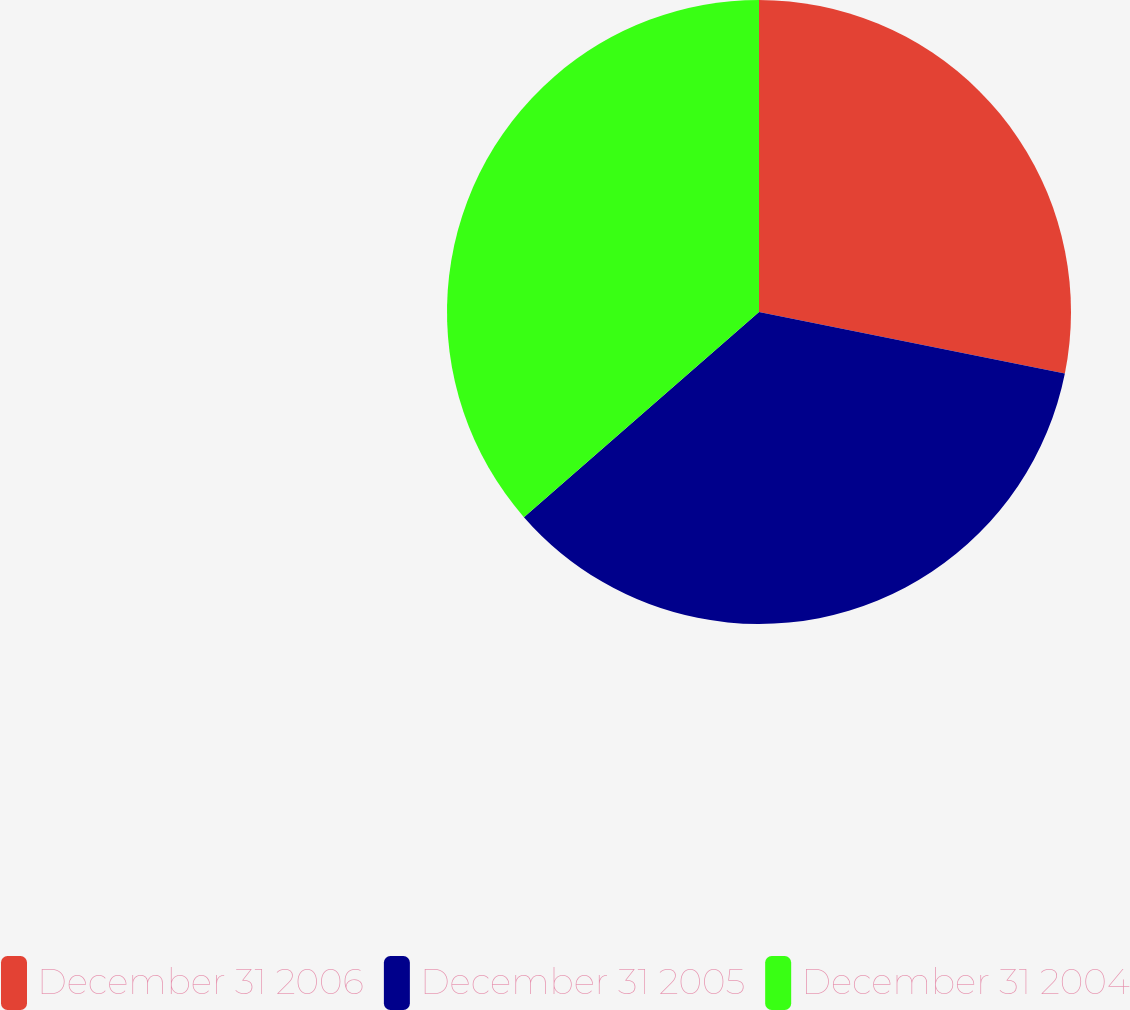<chart> <loc_0><loc_0><loc_500><loc_500><pie_chart><fcel>December 31 2006<fcel>December 31 2005<fcel>December 31 2004<nl><fcel>28.16%<fcel>35.42%<fcel>36.42%<nl></chart> 